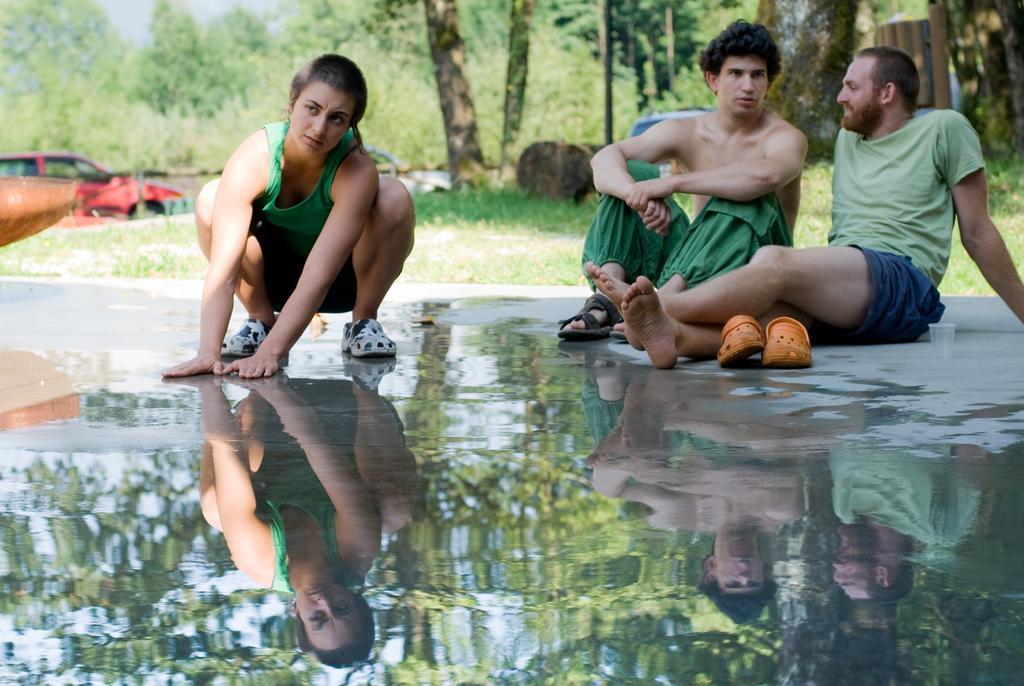Please provide a concise description of this image. In the center of the image there are three persons. At the bottom of the image there is water on the road. In the background of the image there are trees. There is a car. 